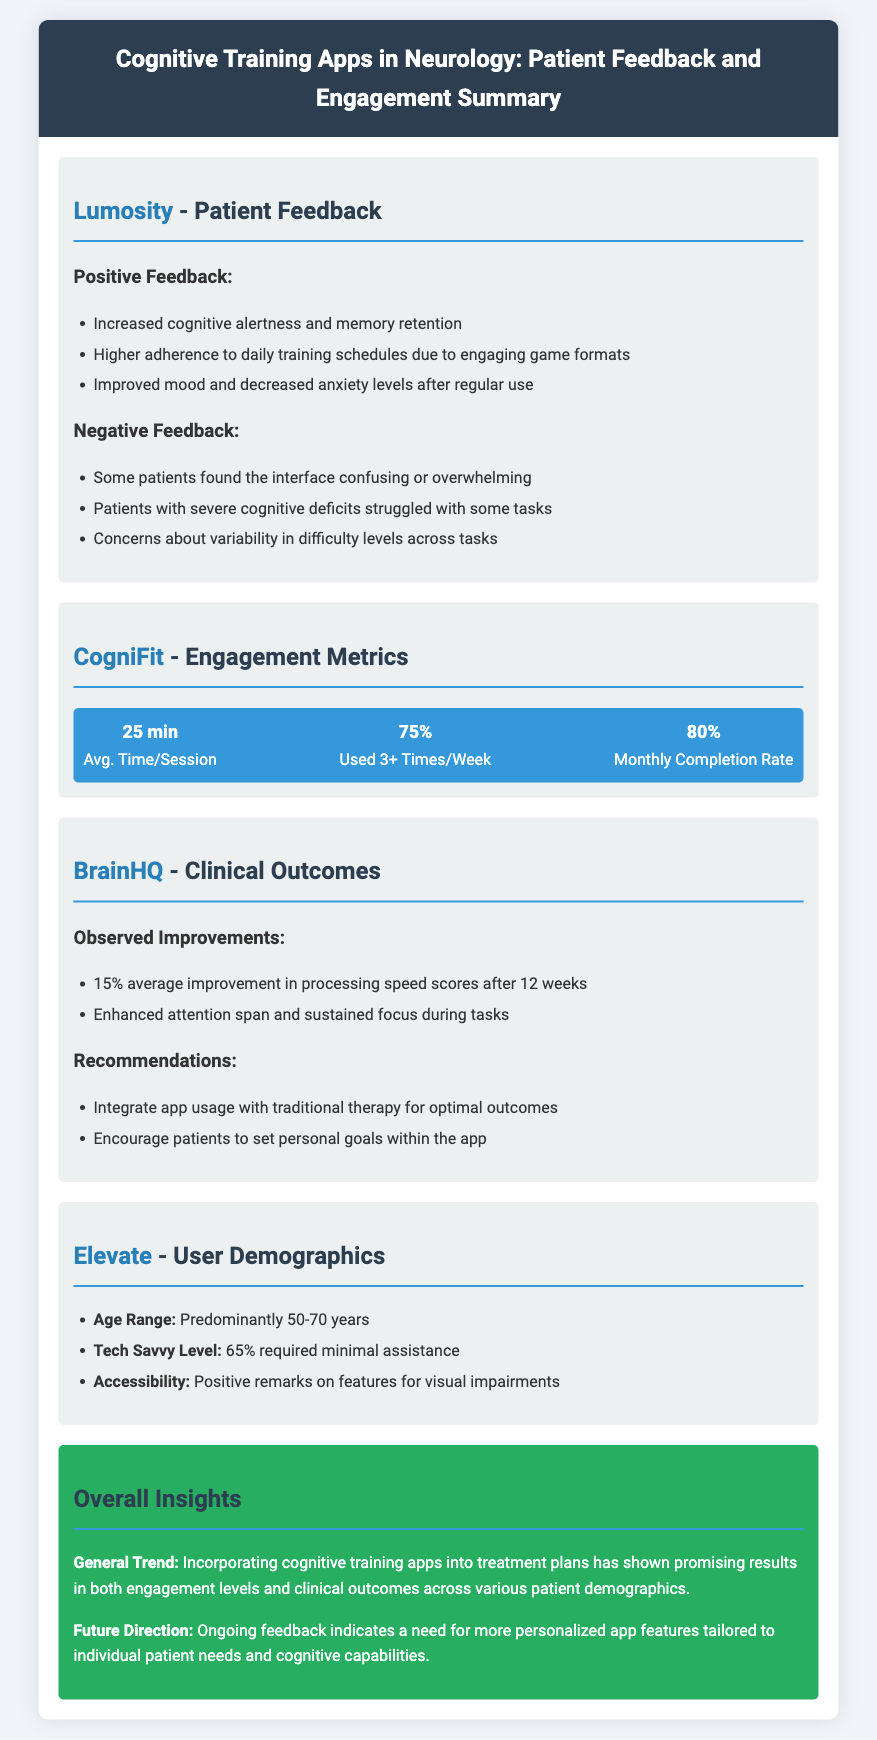what is the average time per session for CogniFit? The average time per session for CogniFit is stated in the engagement metrics section.
Answer: 25 min what percentage of CogniFit users engage 3 or more times a week? This percentage is provided in the engagement metrics section under CogniFit.
Answer: 75% what was the average improvement in processing speed scores observed after using BrainHQ? This information is found under the clinical outcomes section for BrainHQ.
Answer: 15% which cognitive training app had positive remarks for accessibility features? This detail is mentioned in the user demographics section related to Elevate.
Answer: Elevate what is the predominant age range of users for the Elevate app? The predominant age range is given in the user demographics section for Elevate.
Answer: 50-70 years what was a common concern among patients regarding Lumosity's interface? This concern is noted under the negative feedback section for Lumosity.
Answer: Confusing or overwhelming what treatment approach is recommended for optimal outcomes with BrainHQ? This recommendation is listed under the recommendations section for BrainHQ.
Answer: Integrate app usage with traditional therapy how do patients feel about their mood after regular use of Lumosity? This sentiment is described in the positive feedback section for Lumosity.
Answer: Improved mood what is the overall trend regarding cognitive training apps highlighted in the insights section? The trend is summarized in the overall insights section of the document.
Answer: Promising results 